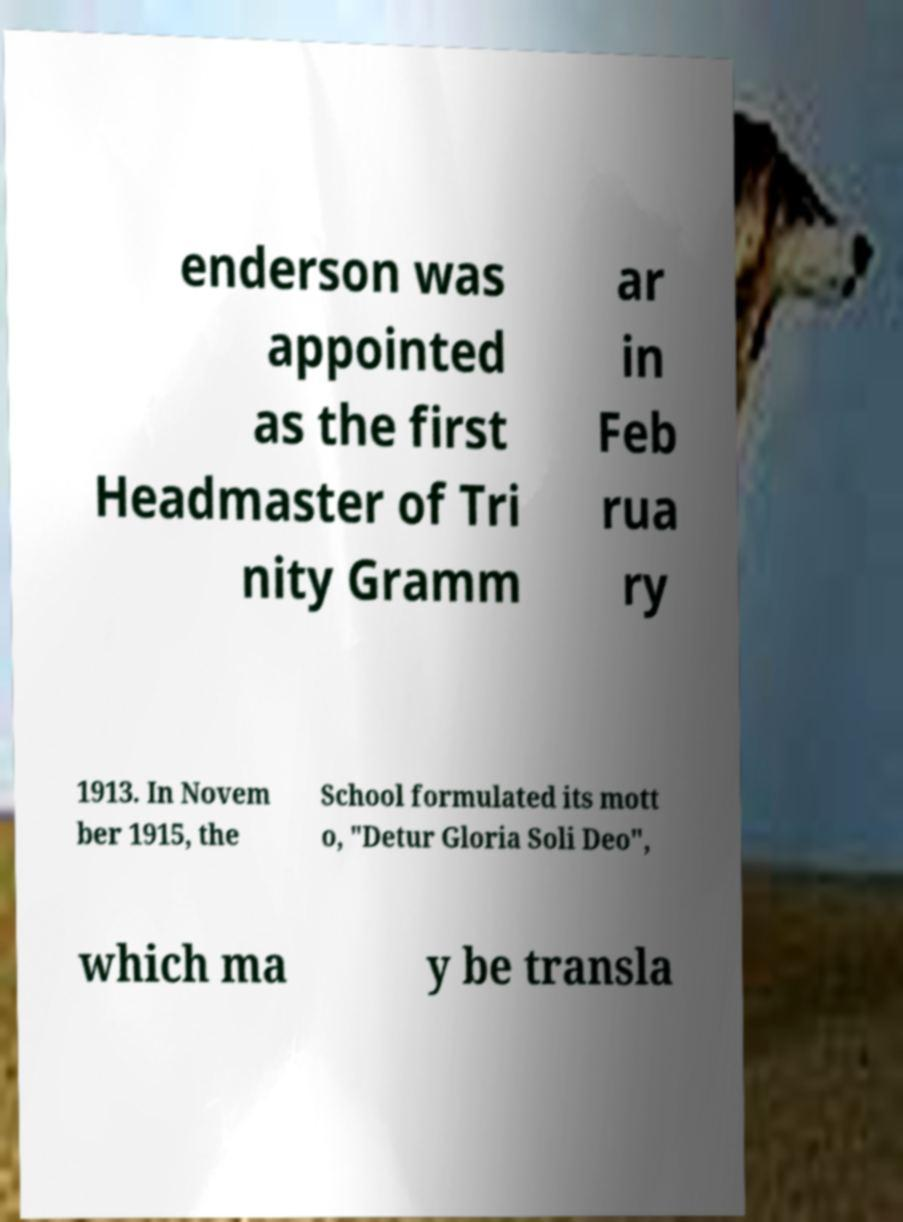Please identify and transcribe the text found in this image. enderson was appointed as the first Headmaster of Tri nity Gramm ar in Feb rua ry 1913. In Novem ber 1915, the School formulated its mott o, "Detur Gloria Soli Deo", which ma y be transla 